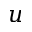Convert formula to latex. <formula><loc_0><loc_0><loc_500><loc_500>u</formula> 